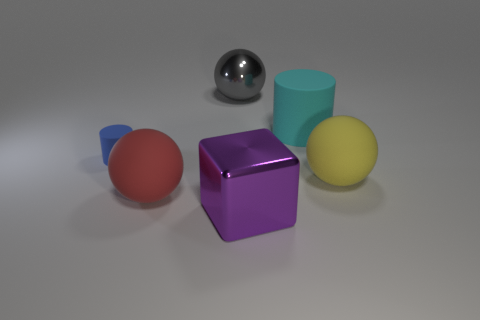There is a big thing that is left of the cyan rubber object and behind the large yellow thing; what material is it?
Keep it short and to the point. Metal. What is the shape of the big purple thing that is the same material as the big gray sphere?
Give a very brief answer. Cube. Is the number of gray things behind the tiny matte thing greater than the number of small gray objects?
Your answer should be compact. Yes. What material is the tiny blue thing?
Your response must be concise. Rubber. What number of green matte cylinders are the same size as the red rubber object?
Make the answer very short. 0. Are there the same number of cyan cylinders that are to the right of the cyan matte thing and large yellow matte objects that are in front of the tiny blue cylinder?
Your answer should be very brief. No. Does the red ball have the same material as the yellow ball?
Your answer should be compact. Yes. There is a big matte object that is in front of the big yellow rubber ball; are there any large things behind it?
Give a very brief answer. Yes. Is there a large cyan thing of the same shape as the tiny matte object?
Your answer should be compact. Yes. There is a large thing in front of the large rubber object that is on the left side of the big cyan rubber cylinder; what is its material?
Your answer should be compact. Metal. 